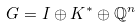Convert formula to latex. <formula><loc_0><loc_0><loc_500><loc_500>G = I \oplus K ^ { * } \oplus \mathbb { Q } ^ { n }</formula> 